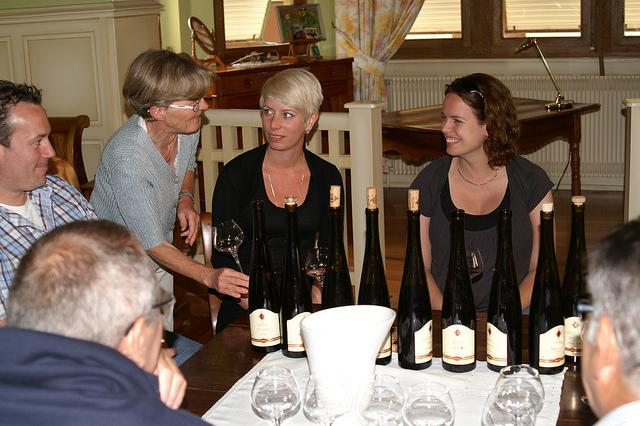What is in the bottle all the way to the right that is near the brunette woman?

Choices:
A) cheese
B) cork
C) milk
D) orange juice cork 